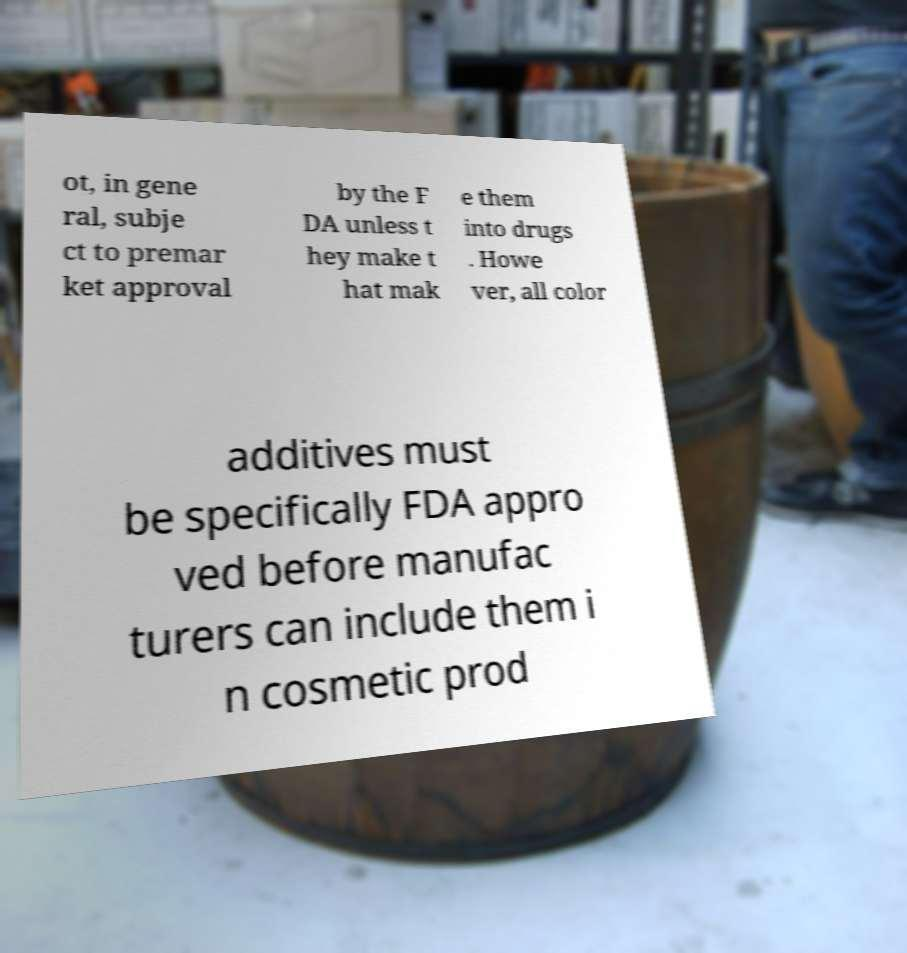Could you extract and type out the text from this image? ot, in gene ral, subje ct to premar ket approval by the F DA unless t hey make t hat mak e them into drugs . Howe ver, all color additives must be specifically FDA appro ved before manufac turers can include them i n cosmetic prod 